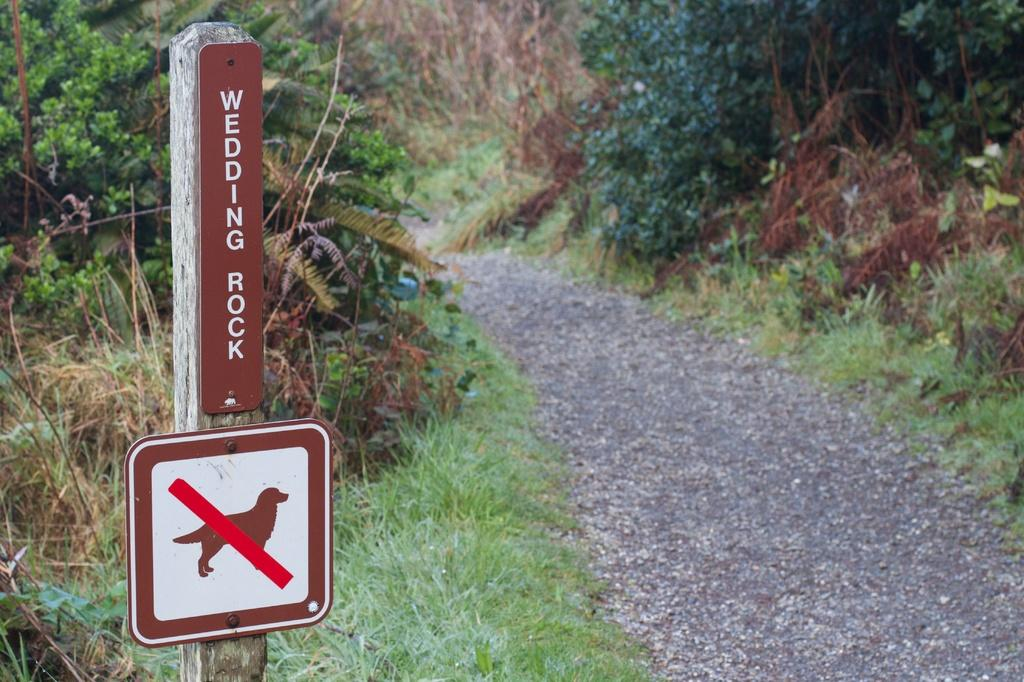What is the main object in the image? There is a board in the image. What can be seen in the background of the image? There are trees in the background of the image. What type of vegetation is visible at the bottom of the image? There is grass at the bottom of the image. What is the surface visible in the image? There is ground visible in the image. What type of foot is visible in the image? There is no foot present in the image. Is there a sidewalk visible in the image? There is no sidewalk present in the image. 